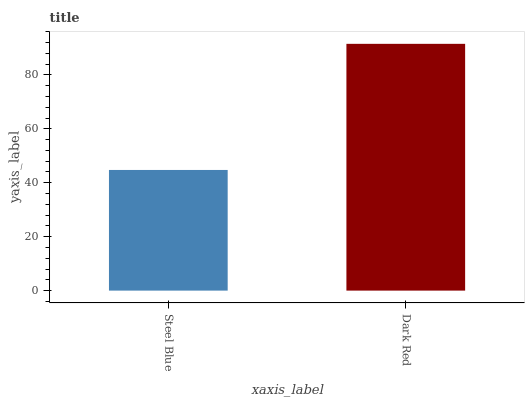Is Steel Blue the minimum?
Answer yes or no. Yes. Is Dark Red the maximum?
Answer yes or no. Yes. Is Dark Red the minimum?
Answer yes or no. No. Is Dark Red greater than Steel Blue?
Answer yes or no. Yes. Is Steel Blue less than Dark Red?
Answer yes or no. Yes. Is Steel Blue greater than Dark Red?
Answer yes or no. No. Is Dark Red less than Steel Blue?
Answer yes or no. No. Is Dark Red the high median?
Answer yes or no. Yes. Is Steel Blue the low median?
Answer yes or no. Yes. Is Steel Blue the high median?
Answer yes or no. No. Is Dark Red the low median?
Answer yes or no. No. 